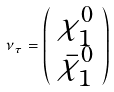Convert formula to latex. <formula><loc_0><loc_0><loc_500><loc_500>\nu _ { \tau } = \left ( \begin{array} { c } \chi _ { 1 } ^ { 0 } \\ \bar { \chi } _ { 1 } ^ { 0 } \end{array} \right )</formula> 